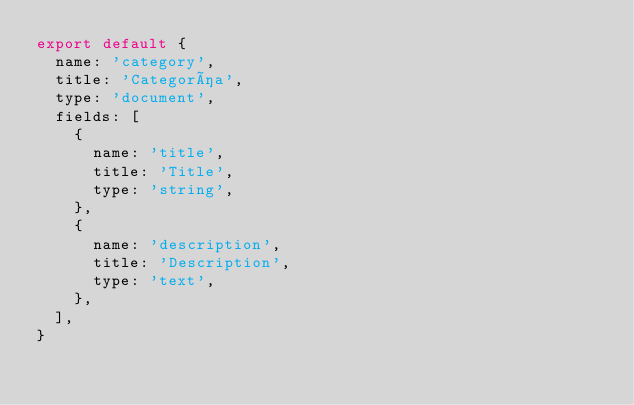Convert code to text. <code><loc_0><loc_0><loc_500><loc_500><_JavaScript_>export default {
  name: 'category',
  title: 'Categoría',
  type: 'document',
  fields: [
    {
      name: 'title',
      title: 'Title',
      type: 'string',
    },
    {
      name: 'description',
      title: 'Description',
      type: 'text',
    },
  ],
}
</code> 